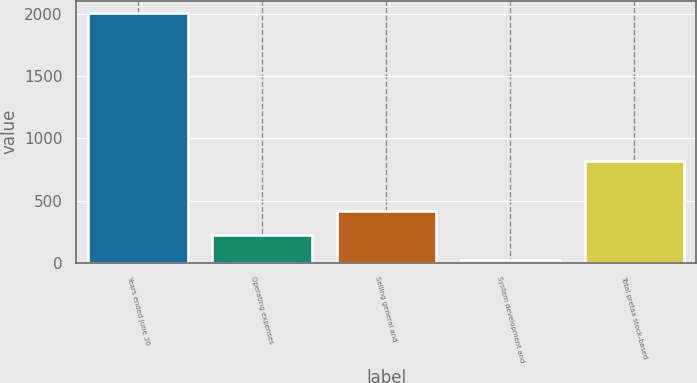Convert chart to OTSL. <chart><loc_0><loc_0><loc_500><loc_500><bar_chart><fcel>Years ended June 30<fcel>Operating expenses<fcel>Selling general and<fcel>System development and<fcel>Total pretax stock-based<nl><fcel>2007<fcel>220.95<fcel>419.4<fcel>22.5<fcel>816.3<nl></chart> 